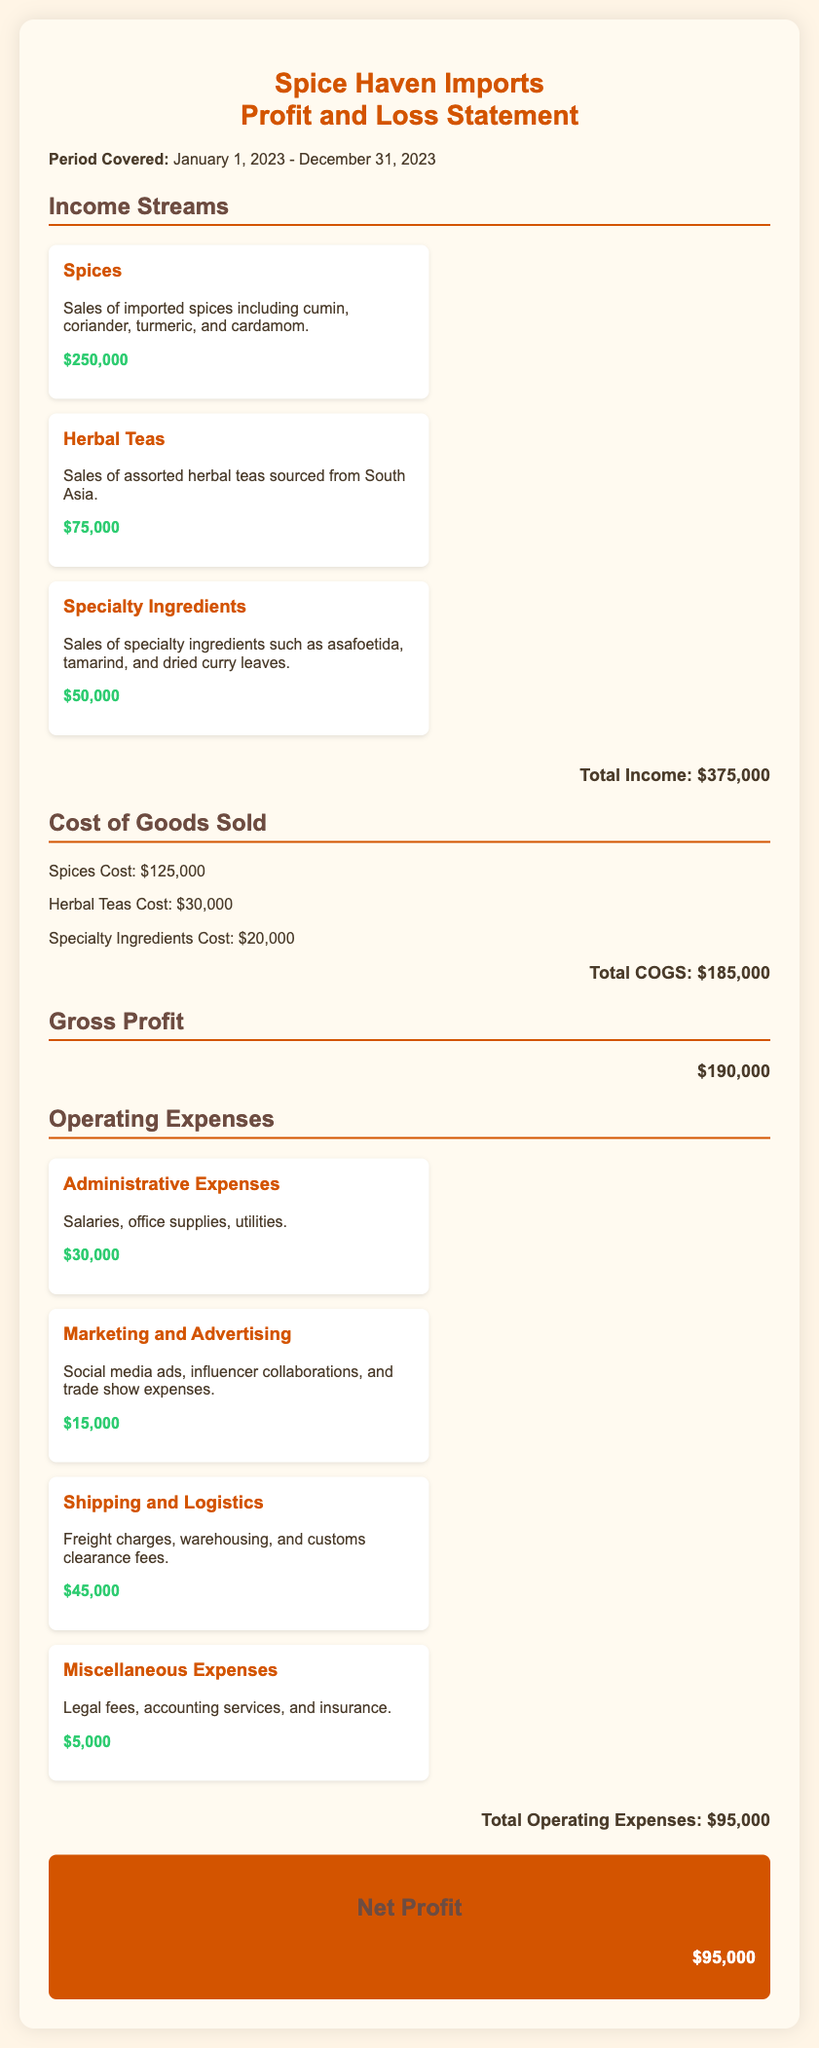what is the total income? The total income is calculated by adding all income streams together, which are $250,000, $75,000, and $50,000.
Answer: $375,000 what is the cost of spices? The document specifies the cost of spices clearly as part of the Cost of Goods Sold section.
Answer: $125,000 how much did the business spend on shipping and logistics? The amount spent on shipping and logistics is listed under Operating Expenses in the document.
Answer: $45,000 what is the total amount of operating expenses? Total operating expenses are calculated by summing all expense items listed in the document, resulting in $30,000, $15,000, $45,000, and $5,000.
Answer: $95,000 what is the gross profit? Gross profit is obtained by subtracting the total Cost of Goods Sold from the total income, which is $375,000 - $185,000.
Answer: $190,000 what period is covered by the Profit and Loss statement? The document clearly states the period covered at the beginning, indicating the start and end dates.
Answer: January 1, 2023 - December 31, 2023 how much was earned from herbal teas? The income from herbal teas is detailed in the Income Streams section, showing the specific amount earned.
Answer: $75,000 what is the net profit? Net profit is calculated by subtracting total operating expenses from gross profit, which is $190,000 - $95,000.
Answer: $95,000 how many types of income streams are listed? The number of income streams is found by counting the distinct categories mentioned in the Income Streams section.
Answer: 3 